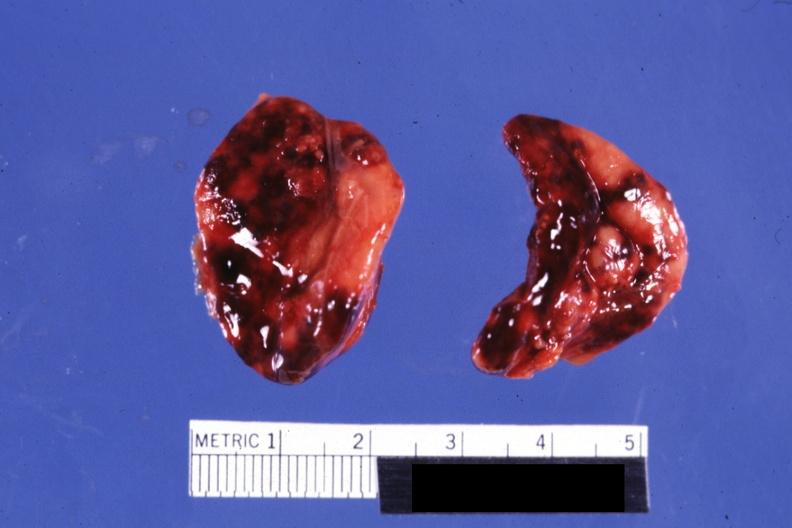what does history look?
Answer the question using a single word or phrase. Like placental abruption 